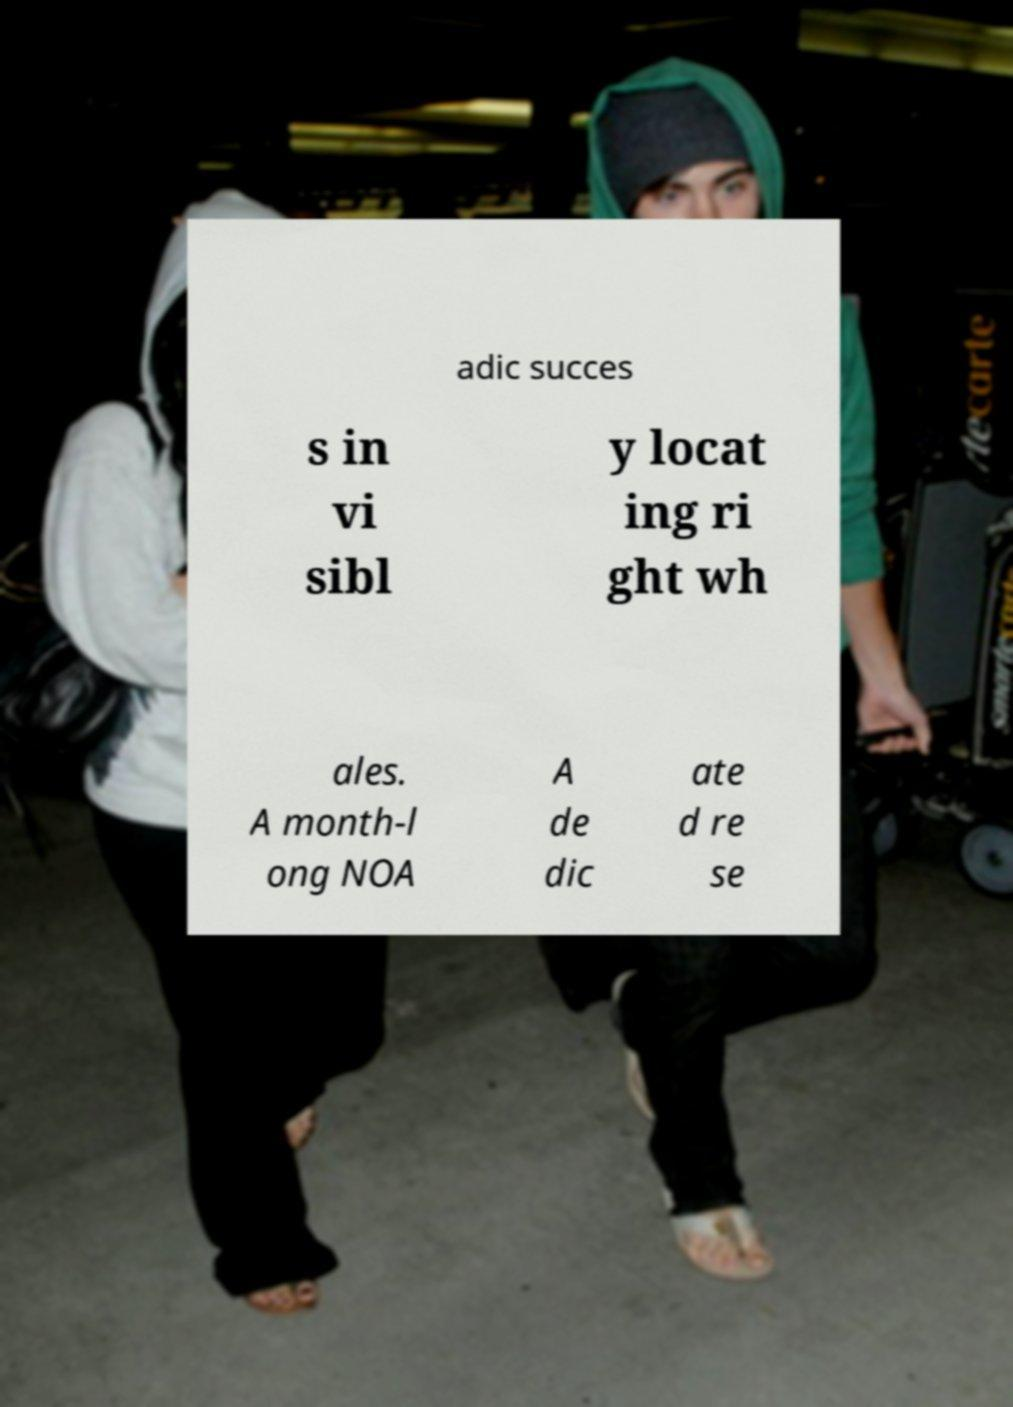Please read and relay the text visible in this image. What does it say? adic succes s in vi sibl y locat ing ri ght wh ales. A month-l ong NOA A de dic ate d re se 